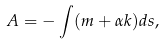<formula> <loc_0><loc_0><loc_500><loc_500>A = - \int ( m + \alpha k ) d s ,</formula> 